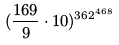Convert formula to latex. <formula><loc_0><loc_0><loc_500><loc_500>( \frac { 1 6 9 } { 9 } \cdot 1 0 ) ^ { 3 6 2 ^ { 4 6 8 } }</formula> 